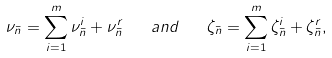Convert formula to latex. <formula><loc_0><loc_0><loc_500><loc_500>\nu _ { \bar { n } } = \sum _ { i = 1 } ^ { m } \nu _ { \bar { n } } ^ { i } + \nu _ { \bar { n } } ^ { r } \quad a n d \quad \zeta _ { \bar { n } } = \sum _ { i = 1 } ^ { m } \zeta _ { \bar { n } } ^ { i } + \zeta _ { \bar { n } } ^ { r } ,</formula> 